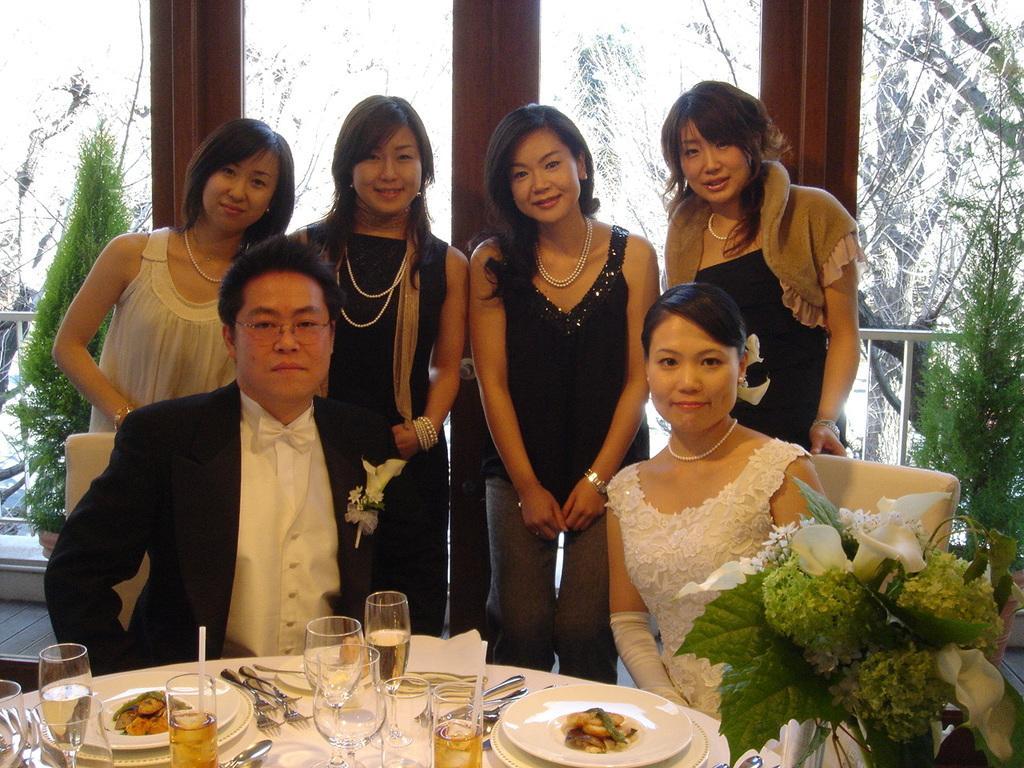In one or two sentences, can you explain what this image depicts? In this image in the front on the table there are glasses, plates, forks, spoons, tissues and in the center there are persons sitting and in the background there are women standing and smiling and there are plants and there are windows and there is a fence. In the front on the right side there are flowers. 